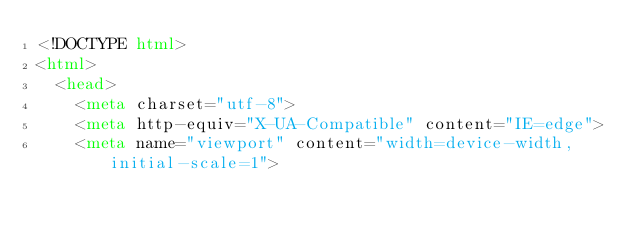Convert code to text. <code><loc_0><loc_0><loc_500><loc_500><_HTML_><!DOCTYPE html>
<html>
  <head>
    <meta charset="utf-8">
    <meta http-equiv="X-UA-Compatible" content="IE=edge">
    <meta name="viewport" content="width=device-width, initial-scale=1">

    </code> 